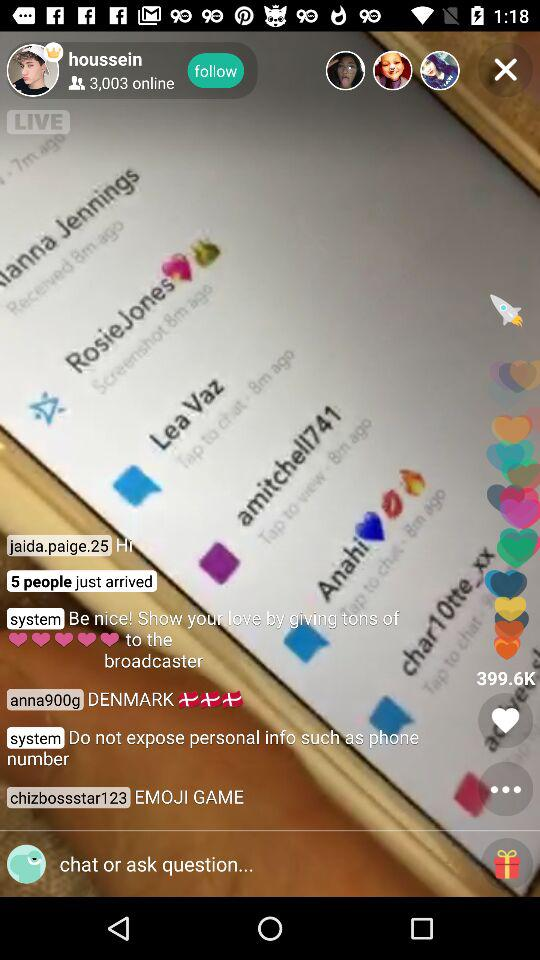How many users are online? There are 3,003 users online. 